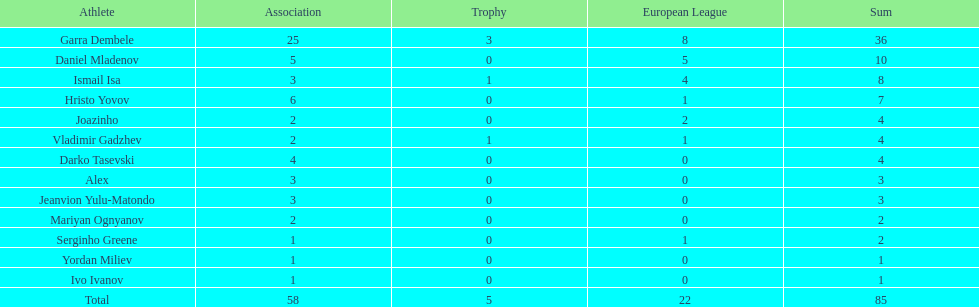What is the disparity between vladimir gadzhev and yordan miliev's tallies? 3. 